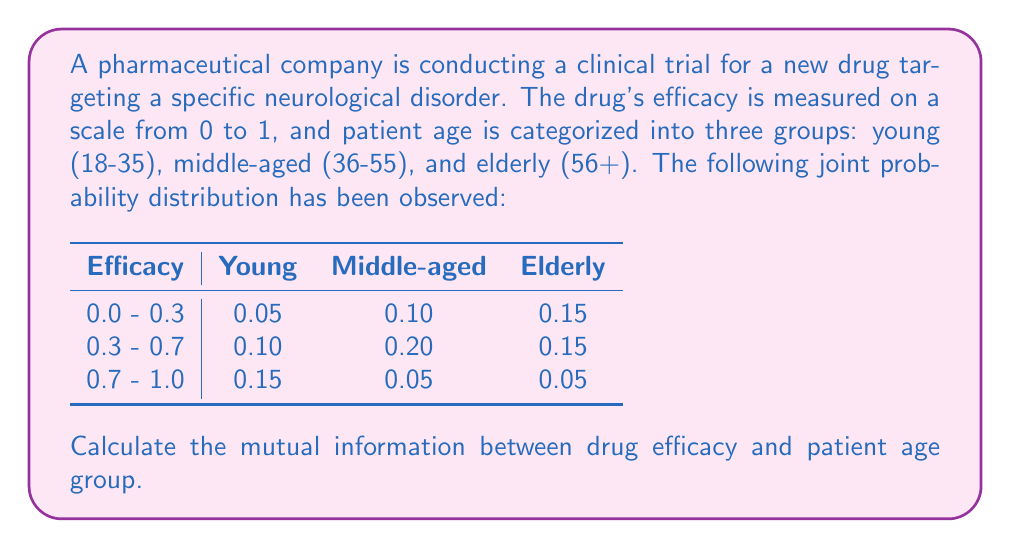Teach me how to tackle this problem. To calculate the mutual information between drug efficacy and patient age group, we'll follow these steps:

1) First, let's calculate the marginal probabilities:

   For efficacy:
   $P(0.0 - 0.3) = 0.05 + 0.10 + 0.15 = 0.30$
   $P(0.3 - 0.7) = 0.10 + 0.20 + 0.15 = 0.45$
   $P(0.7 - 1.0) = 0.15 + 0.05 + 0.05 = 0.25$

   For age groups:
   $P(\text{Young}) = 0.05 + 0.10 + 0.15 = 0.30$
   $P(\text{Middle-aged}) = 0.10 + 0.20 + 0.05 = 0.35$
   $P(\text{Elderly}) = 0.15 + 0.15 + 0.05 = 0.35$

2) The mutual information is given by:

   $I(X;Y) = \sum_{x \in X} \sum_{y \in Y} p(x,y) \log_2 \frac{p(x,y)}{p(x)p(y)}$

3) Let's calculate each term:

   $0.05 \log_2 \frac{0.05}{0.30 \cdot 0.30} = 0.05 \log_2 0.5556 = -0.0424$
   $0.10 \log_2 \frac{0.10}{0.30 \cdot 0.35} = 0.10 \log_2 0.9524 = -0.0070$
   $0.15 \log_2 \frac{0.15}{0.30 \cdot 0.35} = 0.15 \log_2 1.4286 = 0.0613$
   $0.10 \log_2 \frac{0.10}{0.45 \cdot 0.30} = 0.10 \log_2 0.7407 = -0.0360$
   $0.20 \log_2 \frac{0.20}{0.45 \cdot 0.35} = 0.20 \log_2 1.2698 = 0.0457$
   $0.15 \log_2 \frac{0.15}{0.45 \cdot 0.35} = 0.15 \log_2 0.9524 = -0.0105$
   $0.15 \log_2 \frac{0.15}{0.25 \cdot 0.30} = 0.15 \log_2 2.0000 = 0.1505$
   $0.05 \log_2 \frac{0.05}{0.25 \cdot 0.35} = 0.05 \log_2 0.5714 = -0.0406$
   $0.05 \log_2 \frac{0.05}{0.25 \cdot 0.35} = 0.05 \log_2 0.5714 = -0.0406$

4) Sum all these terms:

   $I(X;Y) = -0.0424 - 0.0070 + 0.0613 - 0.0360 + 0.0457 - 0.0105 + 0.1505 - 0.0406 - 0.0406$

5) Calculate the final result:

   $I(X;Y) = 0.0804$ bits
Answer: The mutual information between drug efficacy and patient age group is approximately 0.0804 bits. 